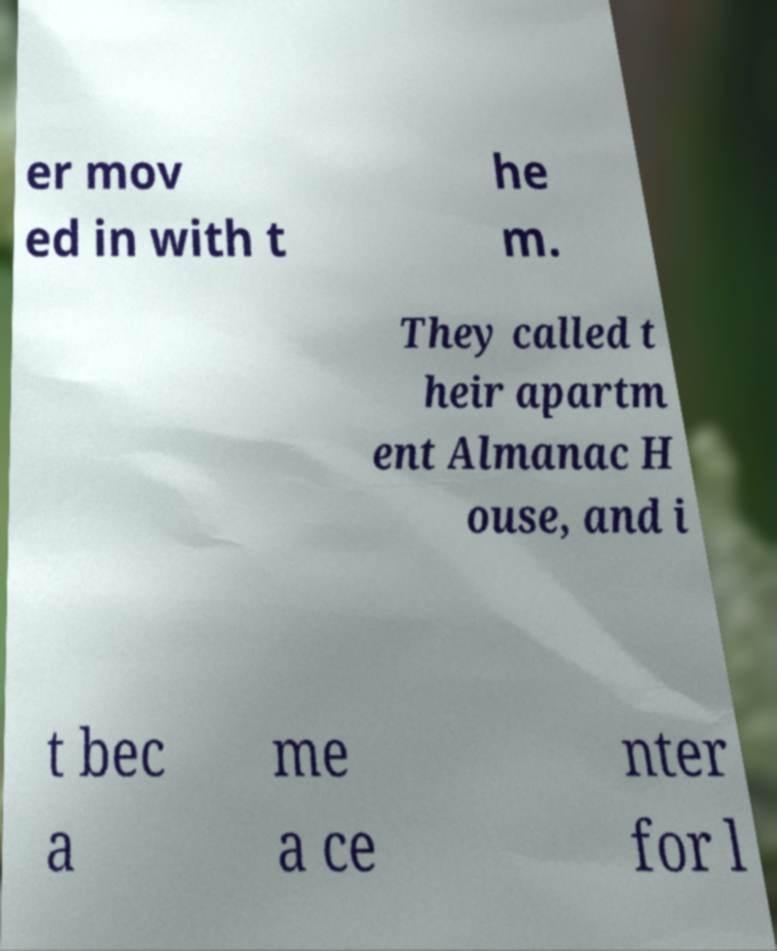What messages or text are displayed in this image? I need them in a readable, typed format. er mov ed in with t he m. They called t heir apartm ent Almanac H ouse, and i t bec a me a ce nter for l 